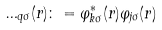<formula> <loc_0><loc_0><loc_500><loc_500>\Phi _ { q \sigma } ( { r } ) \colon = \varphi _ { k \sigma } ^ { * } ( { r } ) \varphi _ { j \sigma } ( { r } )</formula> 